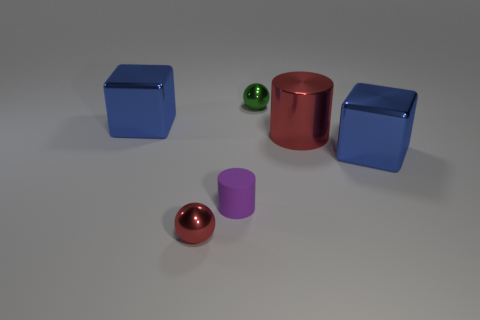Add 2 big cubes. How many objects exist? 8 Subtract all cubes. How many objects are left? 4 Add 4 small spheres. How many small spheres are left? 6 Add 1 tiny cyan rubber cylinders. How many tiny cyan rubber cylinders exist? 1 Subtract 0 gray cylinders. How many objects are left? 6 Subtract all tiny purple matte cylinders. Subtract all blue objects. How many objects are left? 3 